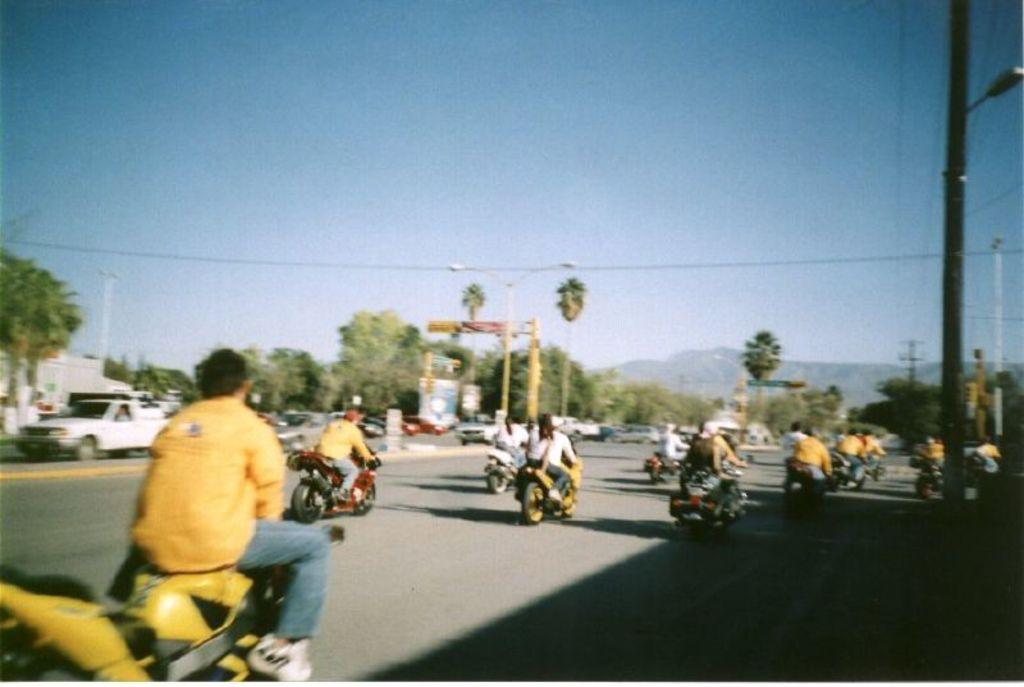What is the color of the sky in the image? The sky is clear and blue in the image. What type of landscape can be seen in the image? There are hills and trees in the image. What are the persons in the image doing? The persons are riding vehicles on the road in the image. Can you describe the light source in the image? There is a light in the image. What is the pole used for in the image? The pole is likely used to support the light in the image. Where is the store located in the image? There is no store present in the image. What type of bucket can be seen in the image? There is no bucket present in the image. 